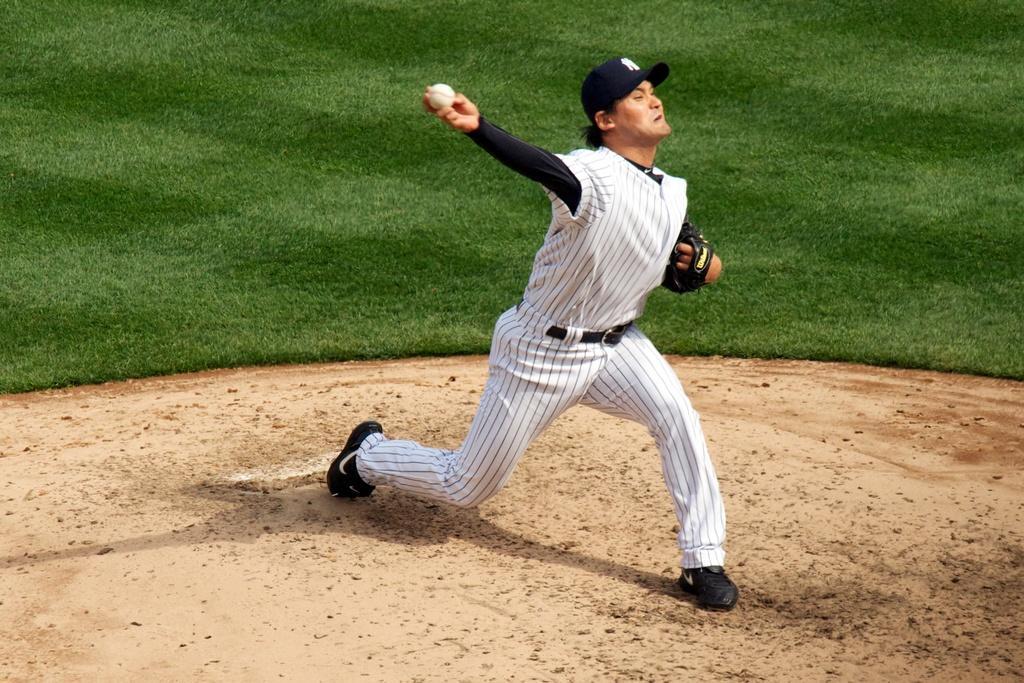Describe this image in one or two sentences. This is a playing ground. Here I can see a person wearing a white color dress, cap on the head, holding a ball in the hand and throwing towards the right side. At the top of the image I can see the grass. 